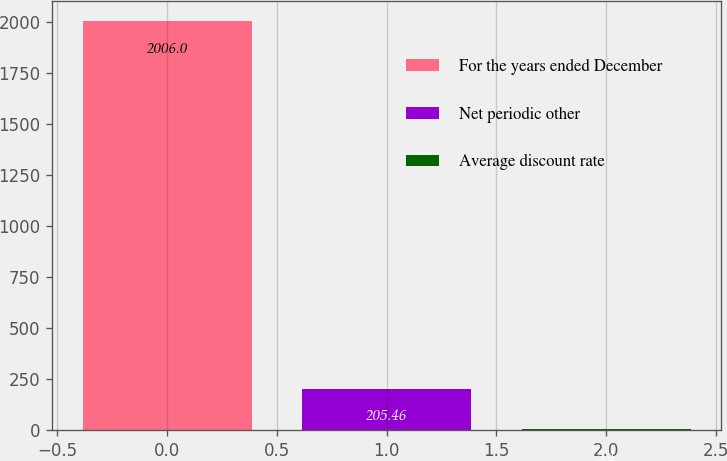<chart> <loc_0><loc_0><loc_500><loc_500><bar_chart><fcel>For the years ended December<fcel>Net periodic other<fcel>Average discount rate<nl><fcel>2006<fcel>205.46<fcel>5.4<nl></chart> 